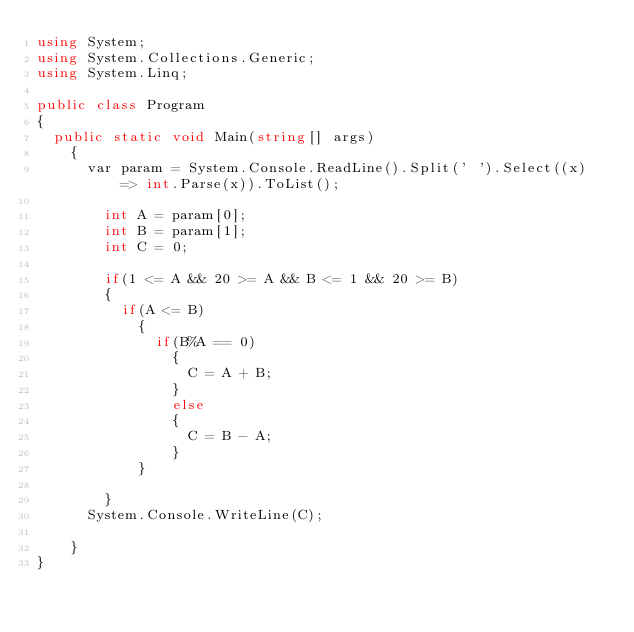Convert code to text. <code><loc_0><loc_0><loc_500><loc_500><_C#_>using System;
using System.Collections.Generic;
using System.Linq;

public class Program
{
	public static void Main(string[] args)
    {
 	   	var param = System.Console.ReadLine().Split(' ').Select((x) => int.Parse(x)).ToList();
    	
      	int A = param[0];
      	int B = param[1];
      	int C = 0;
      
      	if(1 <= A && 20 >= A && B <= 1 && 20 >= B)
        {
        	if(A <= B)
            {
            	if(B%A == 0)
                {
                	C = A + B;
                }
              	else
                {
                	C = B - A;
                }
            }
          	
        }
      System.Console.WriteLine(C);
      
    }
}</code> 